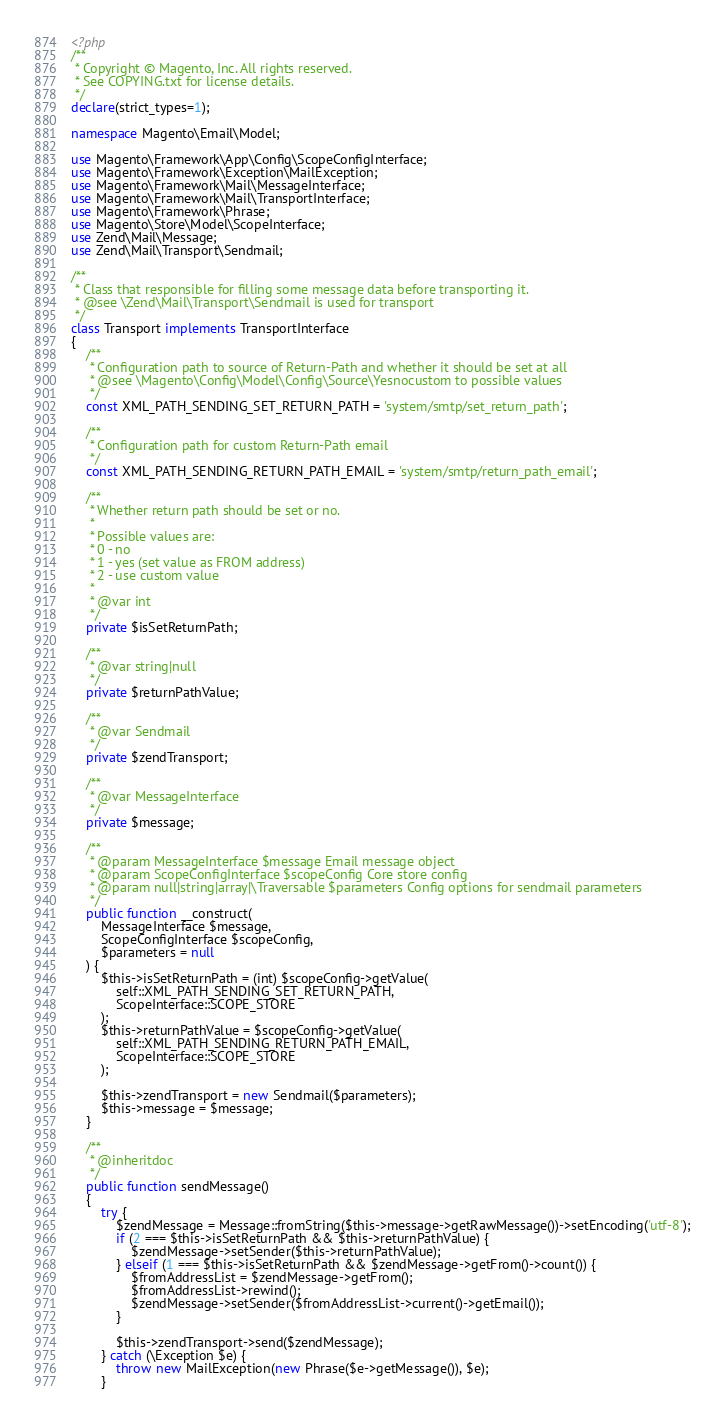<code> <loc_0><loc_0><loc_500><loc_500><_PHP_><?php
/**
 * Copyright © Magento, Inc. All rights reserved.
 * See COPYING.txt for license details.
 */
declare(strict_types=1);

namespace Magento\Email\Model;

use Magento\Framework\App\Config\ScopeConfigInterface;
use Magento\Framework\Exception\MailException;
use Magento\Framework\Mail\MessageInterface;
use Magento\Framework\Mail\TransportInterface;
use Magento\Framework\Phrase;
use Magento\Store\Model\ScopeInterface;
use Zend\Mail\Message;
use Zend\Mail\Transport\Sendmail;

/**
 * Class that responsible for filling some message data before transporting it.
 * @see \Zend\Mail\Transport\Sendmail is used for transport
 */
class Transport implements TransportInterface
{
    /**
     * Configuration path to source of Return-Path and whether it should be set at all
     * @see \Magento\Config\Model\Config\Source\Yesnocustom to possible values
     */
    const XML_PATH_SENDING_SET_RETURN_PATH = 'system/smtp/set_return_path';

    /**
     * Configuration path for custom Return-Path email
     */
    const XML_PATH_SENDING_RETURN_PATH_EMAIL = 'system/smtp/return_path_email';

    /**
     * Whether return path should be set or no.
     *
     * Possible values are:
     * 0 - no
     * 1 - yes (set value as FROM address)
     * 2 - use custom value
     *
     * @var int
     */
    private $isSetReturnPath;

    /**
     * @var string|null
     */
    private $returnPathValue;

    /**
     * @var Sendmail
     */
    private $zendTransport;

    /**
     * @var MessageInterface
     */
    private $message;

    /**
     * @param MessageInterface $message Email message object
     * @param ScopeConfigInterface $scopeConfig Core store config
     * @param null|string|array|\Traversable $parameters Config options for sendmail parameters
     */
    public function __construct(
        MessageInterface $message,
        ScopeConfigInterface $scopeConfig,
        $parameters = null
    ) {
        $this->isSetReturnPath = (int) $scopeConfig->getValue(
            self::XML_PATH_SENDING_SET_RETURN_PATH,
            ScopeInterface::SCOPE_STORE
        );
        $this->returnPathValue = $scopeConfig->getValue(
            self::XML_PATH_SENDING_RETURN_PATH_EMAIL,
            ScopeInterface::SCOPE_STORE
        );

        $this->zendTransport = new Sendmail($parameters);
        $this->message = $message;
    }

    /**
     * @inheritdoc
     */
    public function sendMessage()
    {
        try {
            $zendMessage = Message::fromString($this->message->getRawMessage())->setEncoding('utf-8');
            if (2 === $this->isSetReturnPath && $this->returnPathValue) {
                $zendMessage->setSender($this->returnPathValue);
            } elseif (1 === $this->isSetReturnPath && $zendMessage->getFrom()->count()) {
                $fromAddressList = $zendMessage->getFrom();
                $fromAddressList->rewind();
                $zendMessage->setSender($fromAddressList->current()->getEmail());
            }

            $this->zendTransport->send($zendMessage);
        } catch (\Exception $e) {
            throw new MailException(new Phrase($e->getMessage()), $e);
        }</code> 